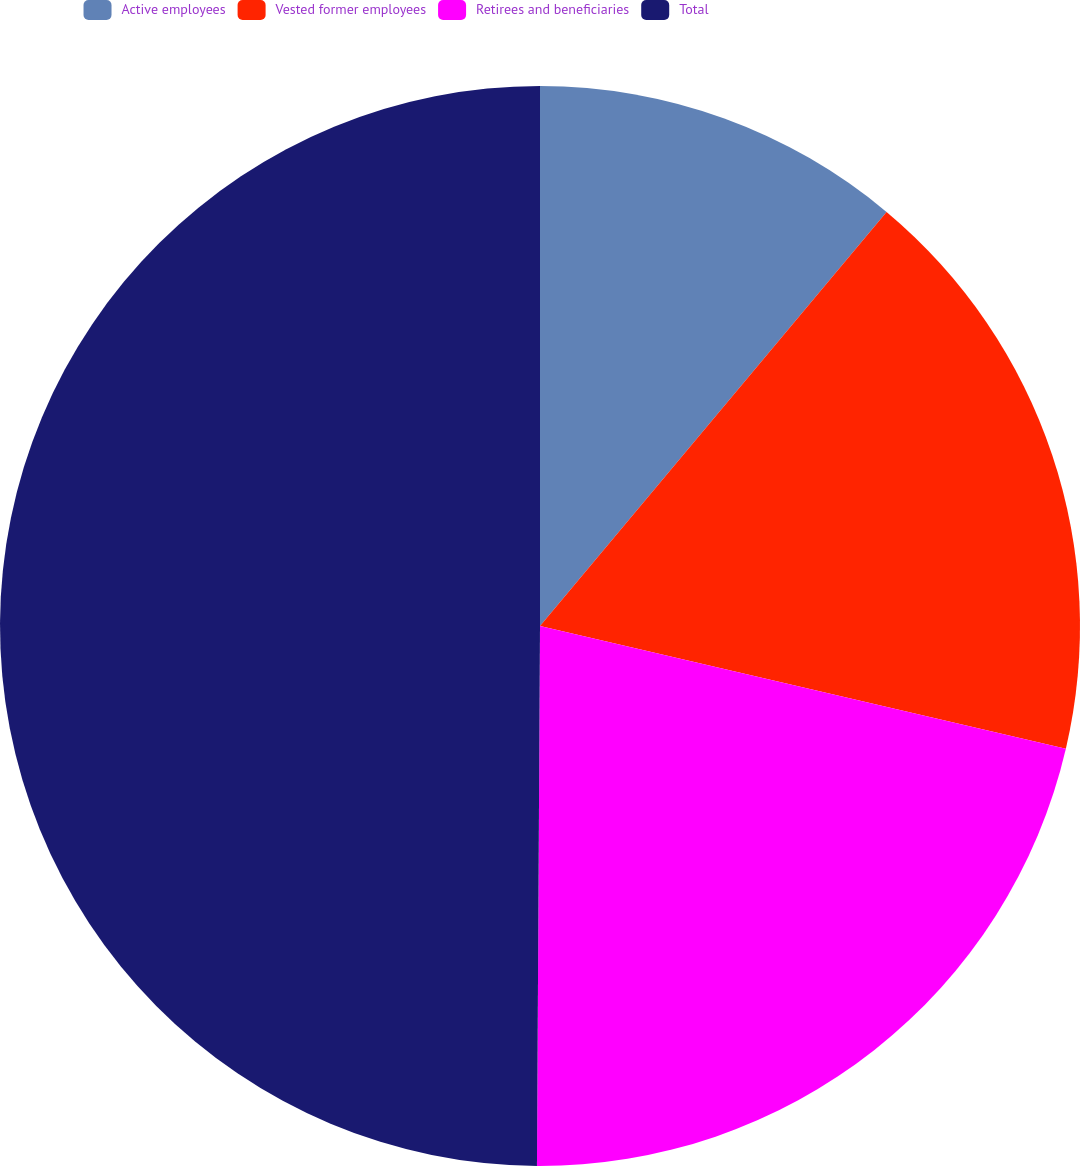Convert chart. <chart><loc_0><loc_0><loc_500><loc_500><pie_chart><fcel>Active employees<fcel>Vested former employees<fcel>Retirees and beneficiaries<fcel>Total<nl><fcel>11.09%<fcel>17.56%<fcel>21.44%<fcel>49.91%<nl></chart> 